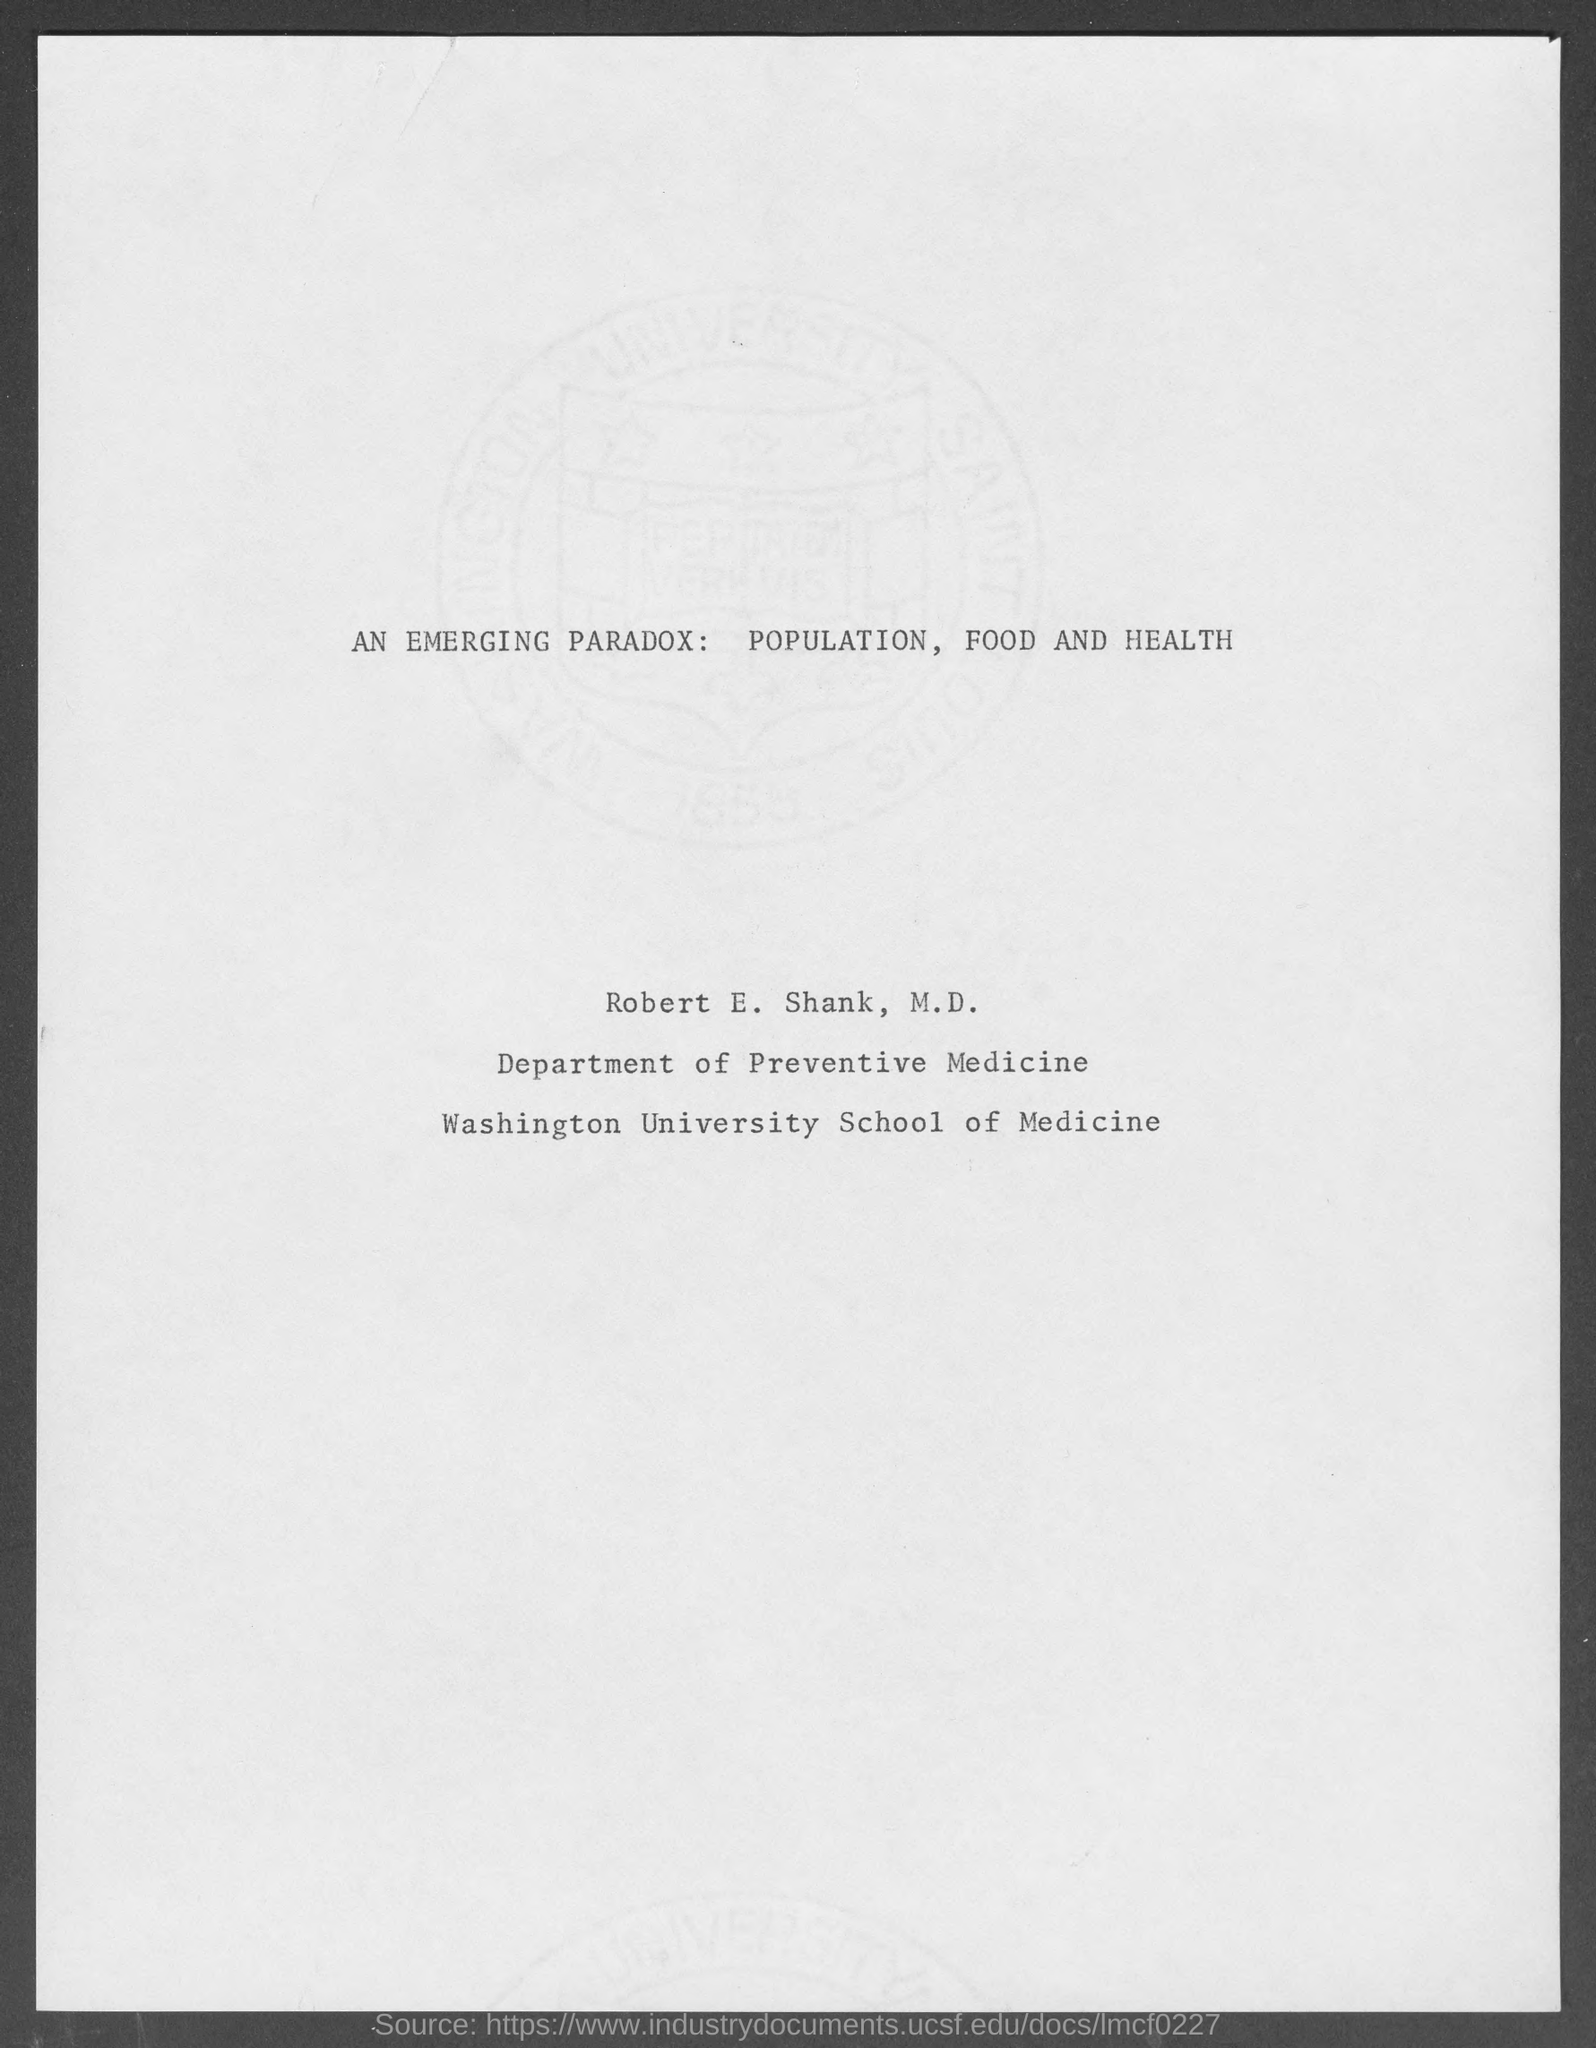In which deparment, Robert E. Shank works?
Offer a very short reply. Department of Preventive Medicine. 